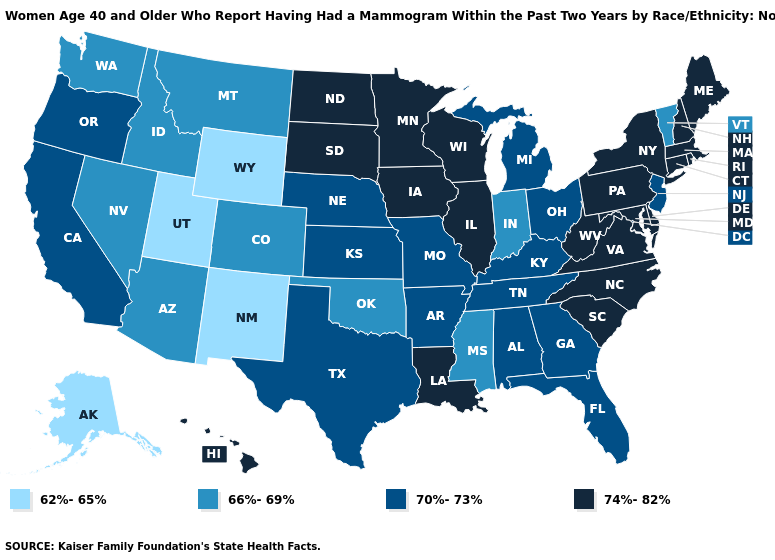Does Washington have the highest value in the West?
Give a very brief answer. No. What is the value of Montana?
Give a very brief answer. 66%-69%. Does Alaska have a lower value than North Carolina?
Give a very brief answer. Yes. Does Mississippi have the highest value in the USA?
Short answer required. No. What is the value of Iowa?
Give a very brief answer. 74%-82%. What is the value of Indiana?
Quick response, please. 66%-69%. Does the map have missing data?
Short answer required. No. What is the value of Virginia?
Write a very short answer. 74%-82%. Name the states that have a value in the range 74%-82%?
Concise answer only. Connecticut, Delaware, Hawaii, Illinois, Iowa, Louisiana, Maine, Maryland, Massachusetts, Minnesota, New Hampshire, New York, North Carolina, North Dakota, Pennsylvania, Rhode Island, South Carolina, South Dakota, Virginia, West Virginia, Wisconsin. What is the lowest value in the MidWest?
Keep it brief. 66%-69%. Does North Carolina have the highest value in the USA?
Keep it brief. Yes. What is the value of Massachusetts?
Short answer required. 74%-82%. Is the legend a continuous bar?
Give a very brief answer. No. What is the highest value in states that border Arizona?
Be succinct. 70%-73%. Among the states that border Ohio , does Pennsylvania have the highest value?
Write a very short answer. Yes. 